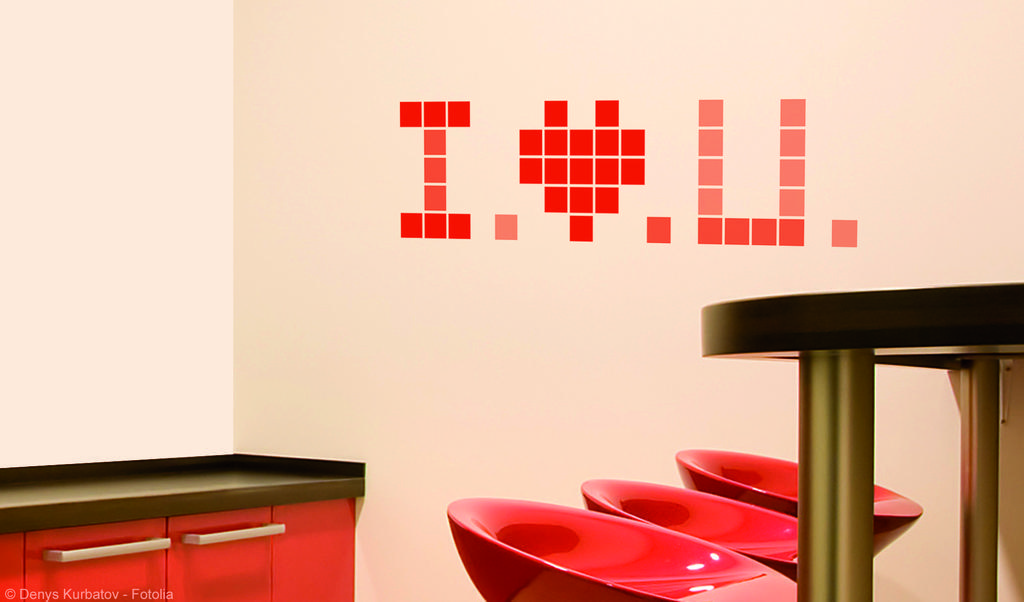Could you give a brief overview of what you see in this image? This pictures show few chairs and a table and we see a cupboard on the back and we see a white wall with red color text on it. 